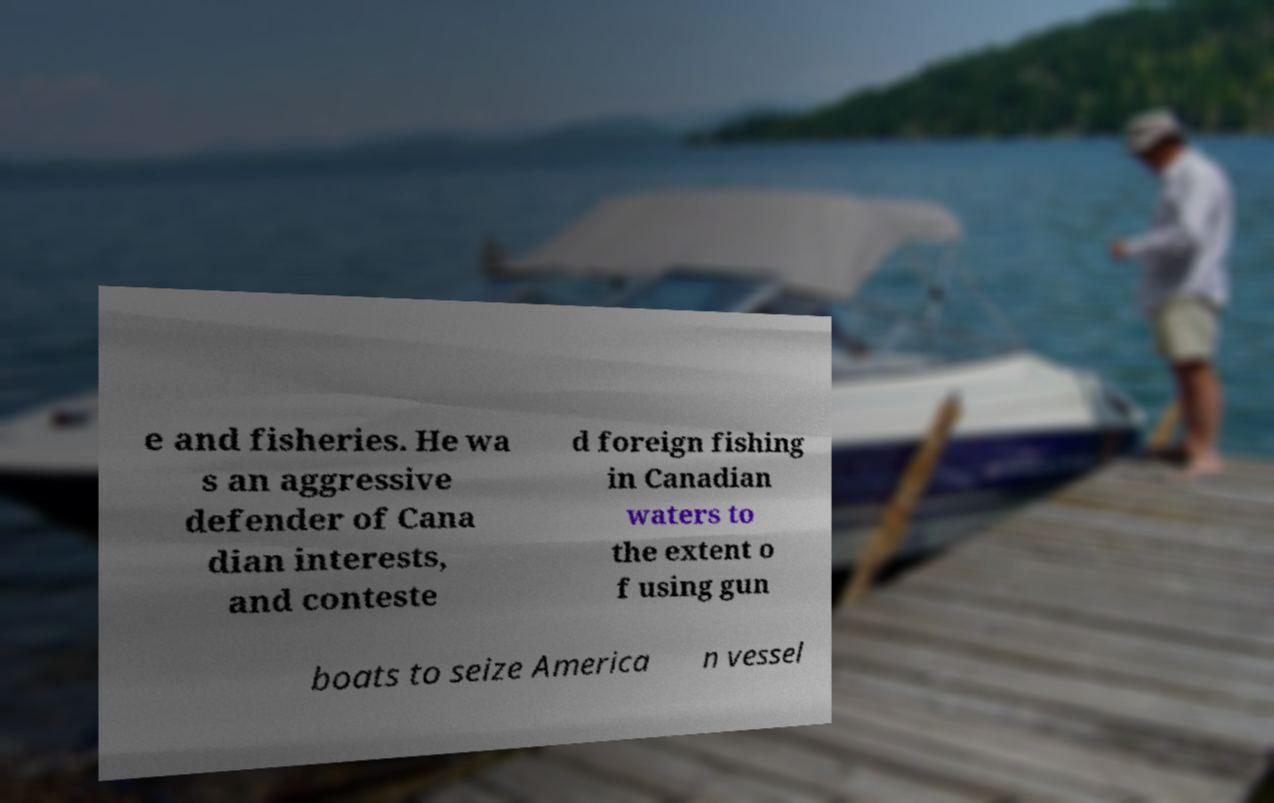Please read and relay the text visible in this image. What does it say? e and fisheries. He wa s an aggressive defender of Cana dian interests, and conteste d foreign fishing in Canadian waters to the extent o f using gun boats to seize America n vessel 